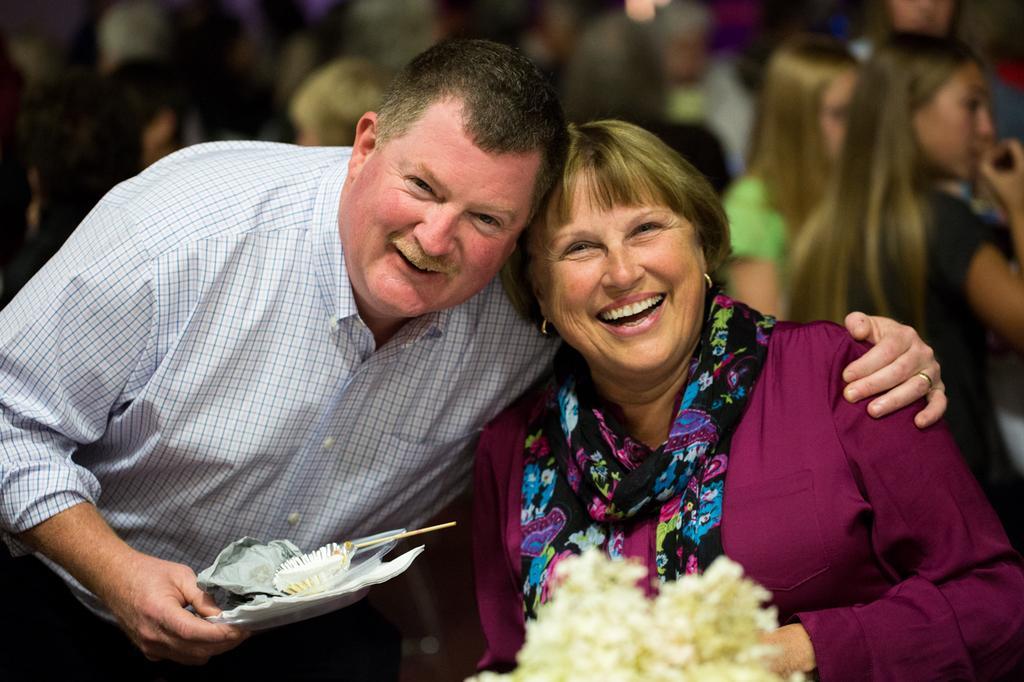How would you summarize this image in a sentence or two? In this picture I can observe a man and woman. Man is holding a plate in his hand. Both of them are smiling. In the background I can observe some people. 